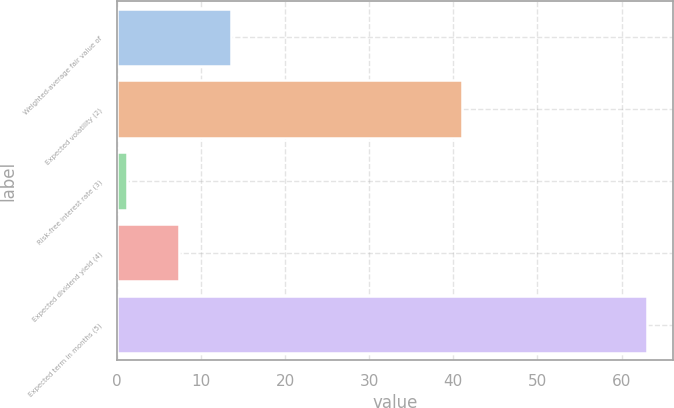<chart> <loc_0><loc_0><loc_500><loc_500><bar_chart><fcel>Weighted-average fair value of<fcel>Expected volatility (2)<fcel>Risk-free interest rate (3)<fcel>Expected dividend yield (4)<fcel>Expected term in months (5)<nl><fcel>13.56<fcel>41<fcel>1.2<fcel>7.38<fcel>63<nl></chart> 